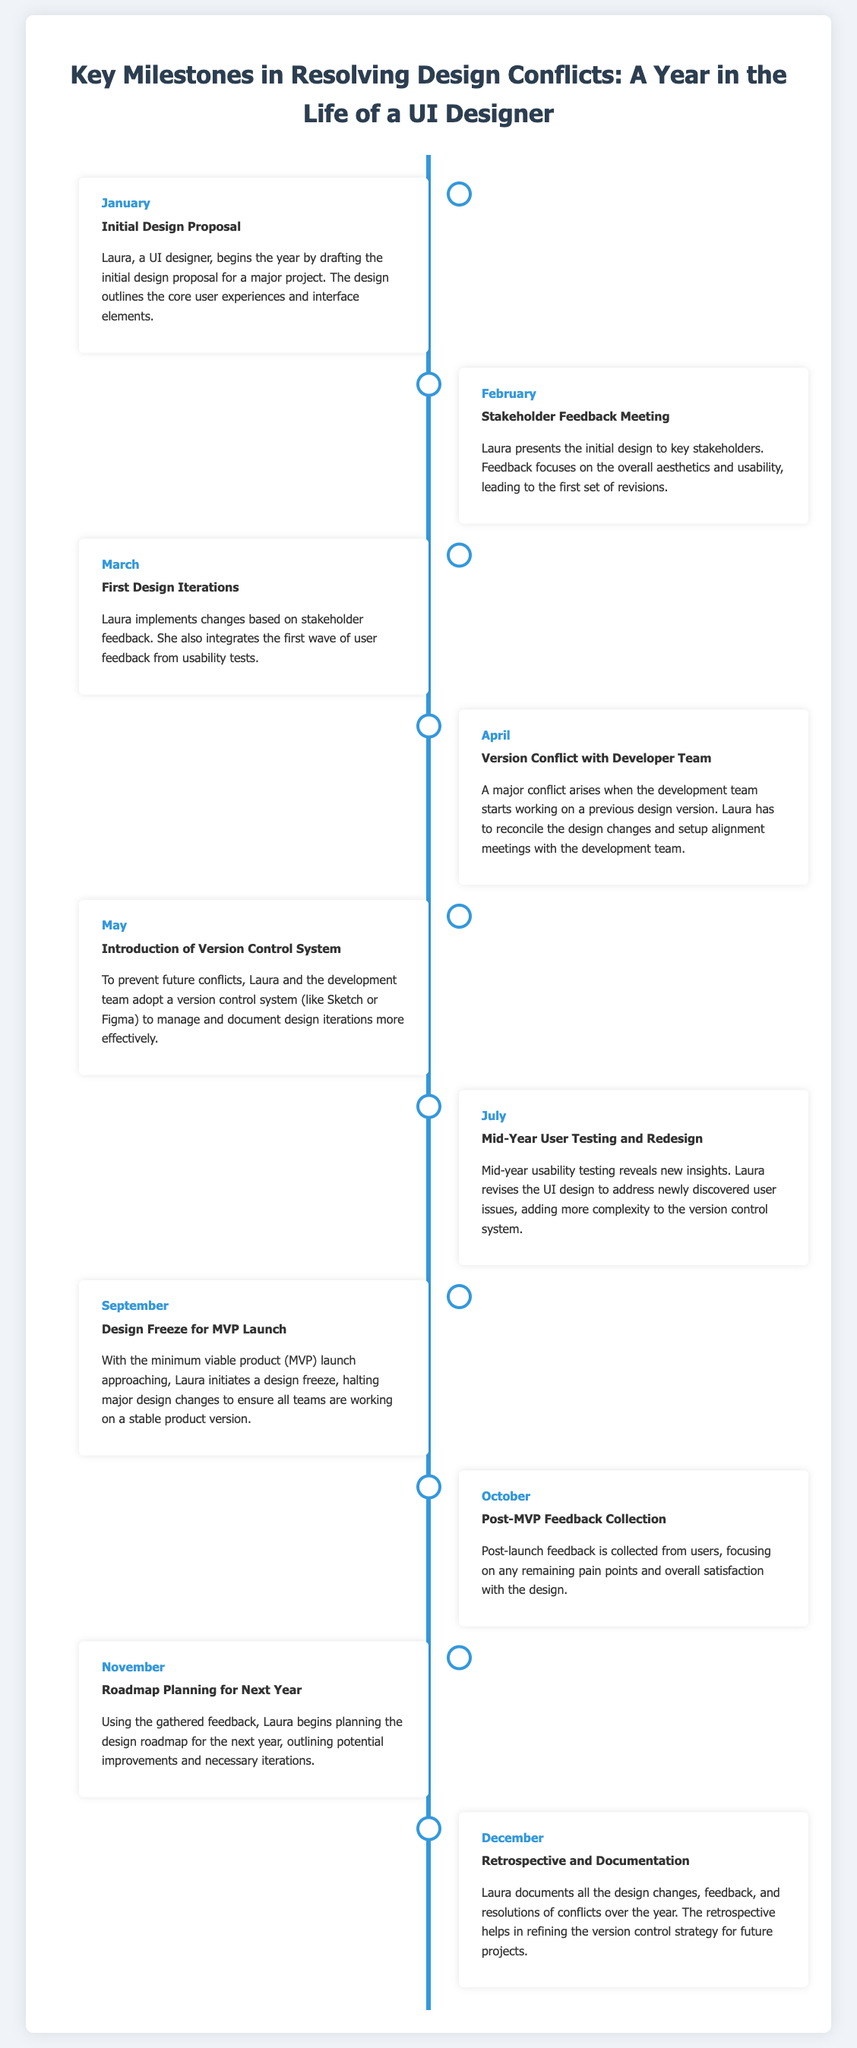What is the first milestone in January? The first milestone in January is the Initial Design Proposal, which Laura drafts for a major project.
Answer: Initial Design Proposal What event occurred in April? In April, a Version Conflict with the Developer Team occurred, as they started working on a previous design version.
Answer: Version Conflict with Developer Team How many months are covered in the timeline? The timeline covers milestones from January to December, which is a total of 12 months.
Answer: 12 What month involves the introduction of a version control system? The introduction of a version control system took place in May.
Answer: May What is the focus of the feedback collected in October? The focus of the feedback collected in October is on post-MVP feedback from users regarding pain points and satisfaction.
Answer: Post-MVP Feedback Collection Which month did Laura conduct mid-year user testing? Laura conducted mid-year user testing in July, revealing new insights.
Answer: July What is the purpose of the design freeze in September? The design freeze in September aims to ensure stability before the minimum viable product launch by halting major design changes.
Answer: To ensure stability In which month does Laura document all design changes? Laura documents all design changes, feedback, and resolutions in December.
Answer: December What is Laura planning in November? In November, Laura begins planning the design roadmap for the next year based on the collected feedback.
Answer: Roadmap Planning for Next Year 